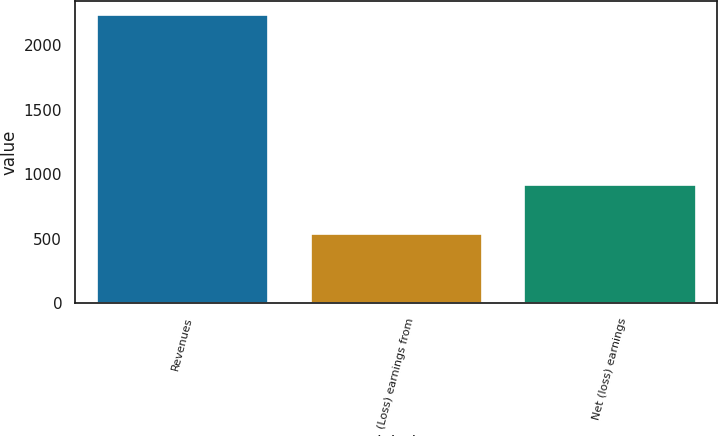<chart> <loc_0><loc_0><loc_500><loc_500><bar_chart><fcel>Revenues<fcel>(Loss) earnings from<fcel>Net (loss) earnings<nl><fcel>2232<fcel>540<fcel>916<nl></chart> 